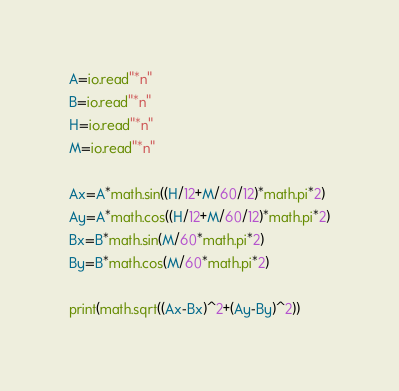<code> <loc_0><loc_0><loc_500><loc_500><_Lua_>A=io.read"*n"
B=io.read"*n"
H=io.read"*n"
M=io.read"*n"

Ax=A*math.sin((H/12+M/60/12)*math.pi*2)
Ay=A*math.cos((H/12+M/60/12)*math.pi*2)
Bx=B*math.sin(M/60*math.pi*2)
By=B*math.cos(M/60*math.pi*2)

print(math.sqrt((Ax-Bx)^2+(Ay-By)^2))</code> 